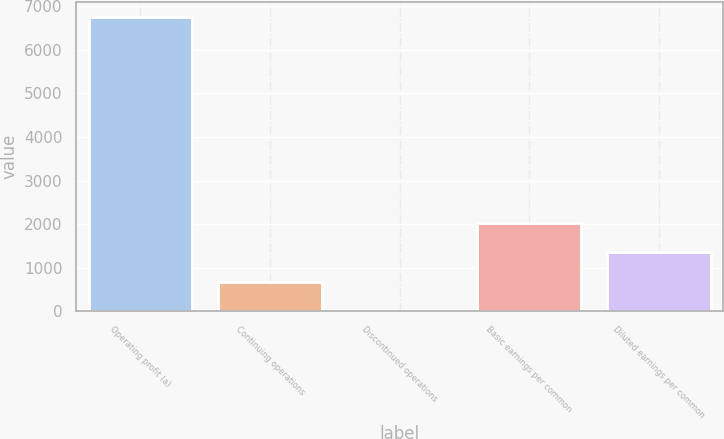Convert chart to OTSL. <chart><loc_0><loc_0><loc_500><loc_500><bar_chart><fcel>Operating profit (a)<fcel>Continuing operations<fcel>Discontinued operations<fcel>Basic earnings per common<fcel>Diluted earnings per common<nl><fcel>6759<fcel>676.13<fcel>0.26<fcel>2027.87<fcel>1352<nl></chart> 